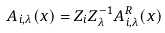Convert formula to latex. <formula><loc_0><loc_0><loc_500><loc_500>A _ { i , \lambda } ( x ) = Z _ { i } Z _ { \lambda } ^ { - 1 } A _ { i , \lambda } ^ { R } ( x )</formula> 